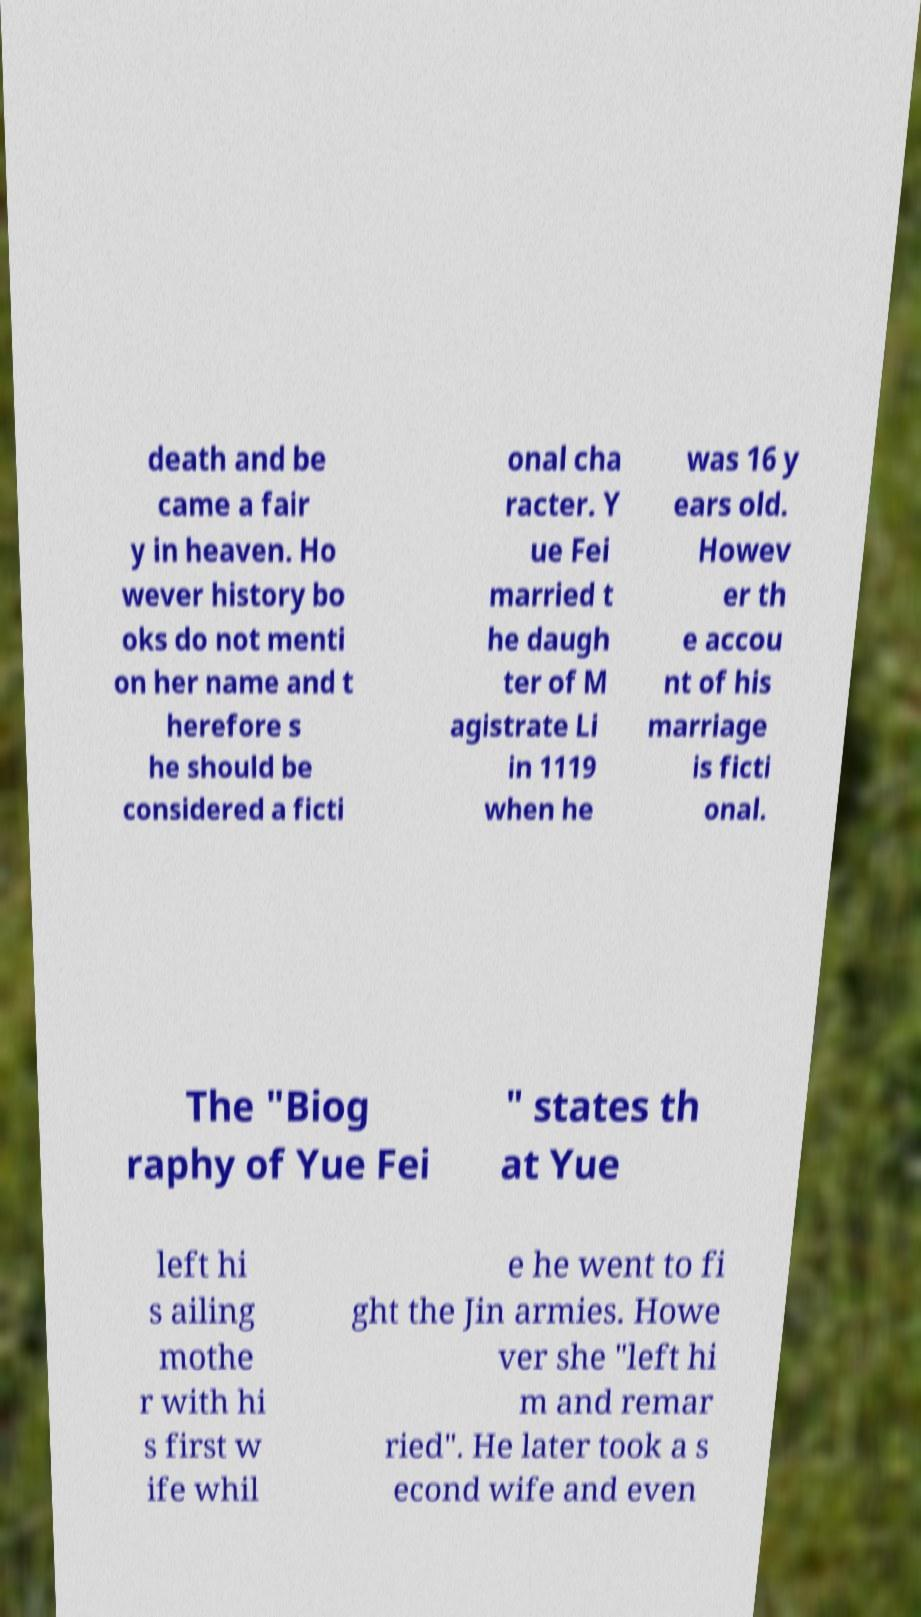Could you assist in decoding the text presented in this image and type it out clearly? death and be came a fair y in heaven. Ho wever history bo oks do not menti on her name and t herefore s he should be considered a ficti onal cha racter. Y ue Fei married t he daugh ter of M agistrate Li in 1119 when he was 16 y ears old. Howev er th e accou nt of his marriage is ficti onal. The "Biog raphy of Yue Fei " states th at Yue left hi s ailing mothe r with hi s first w ife whil e he went to fi ght the Jin armies. Howe ver she "left hi m and remar ried". He later took a s econd wife and even 